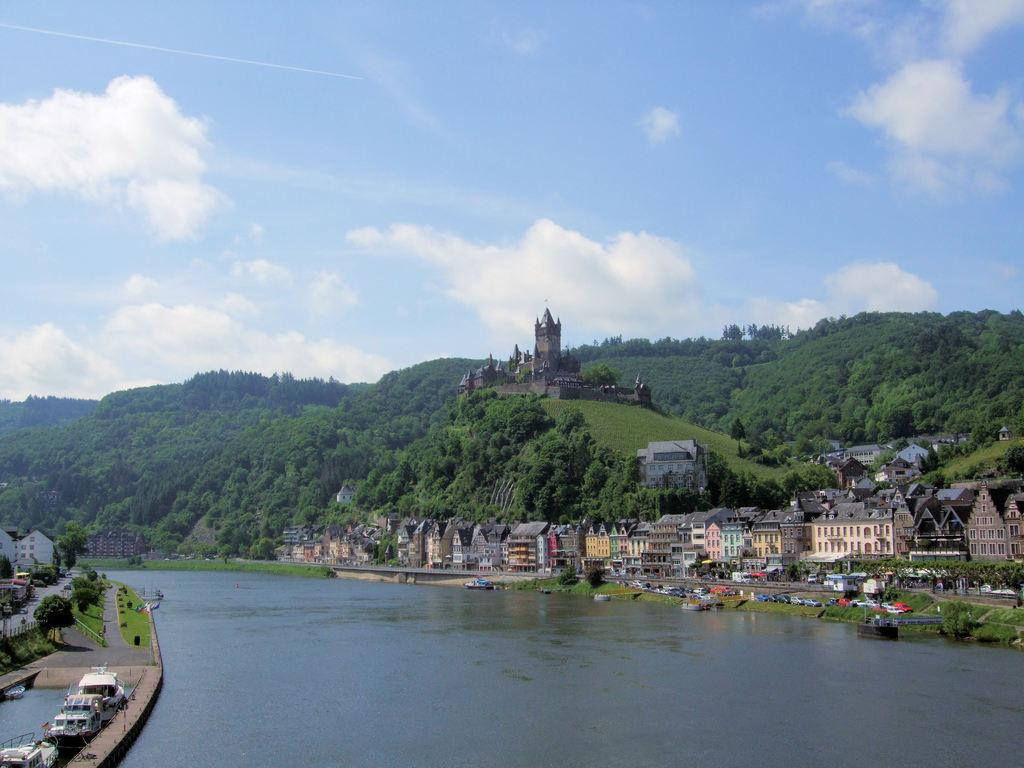What type of structures can be seen in the image? There are buildings in the image. What natural elements are present in the image? There are trees and water visible in the image. What else can be seen in the sky besides the water? There is sky visible in the image. What type of transportation is present in the image? There are boats in the image. Where are the dolls sitting on the sofa in the image? There are no dolls or sofas present in the image. 